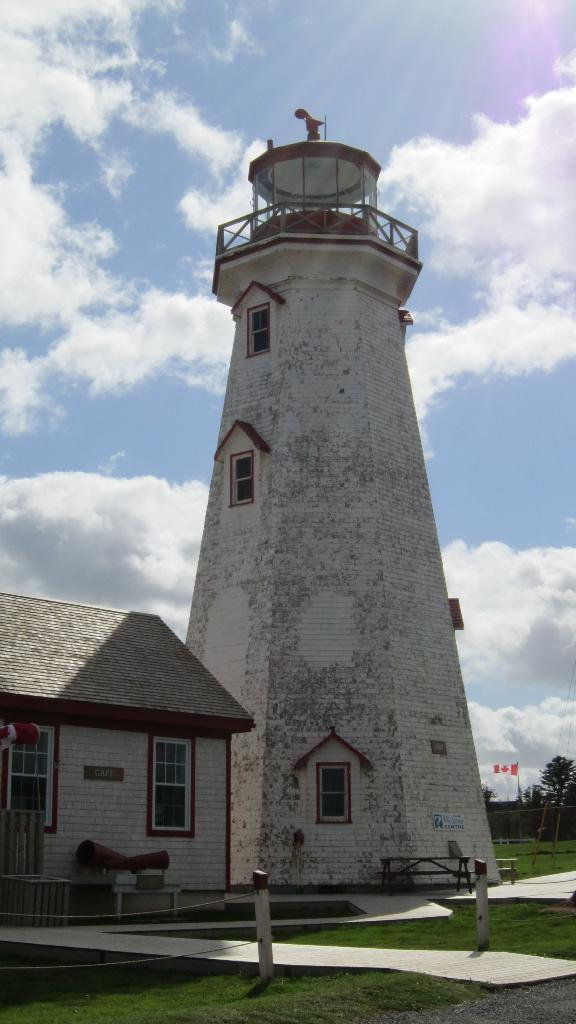What structure is located on the left side of the image? There is a house on the left side of the image. What can be seen in the middle of the image? There appears to be a tower in the middle of the image. What type of vegetation is on the right side of the image? There are trees on the right side of the image. What is visible at the top of the image? The sky is visible at the top of the image. What type of metal is used to construct the tower in the image? There is no information about the construction material of the tower in the image, so we cannot determine the type of metal used. Can you see anyone kicking a soccer ball in the image? There is no soccer ball or person kicking a soccer ball present in the image. 